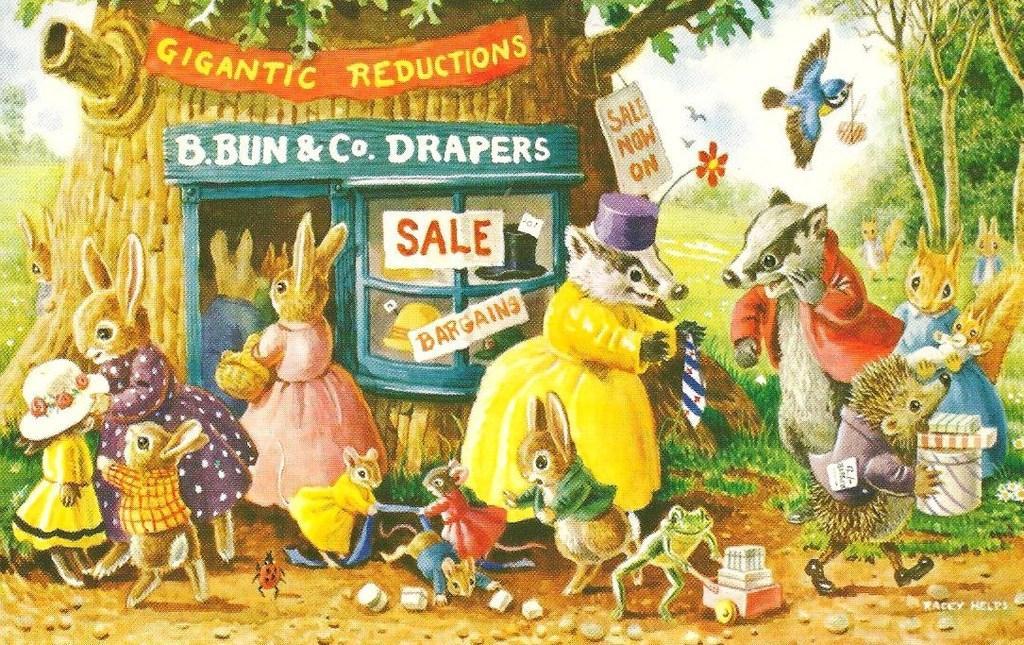How would you summarize this image in a sentence or two? This looks like a poster. There are trees in this image. There is a small store in this image. There are animals, which are wearing dresses in this image. There are so many types of animals. There is a bird at the top. 